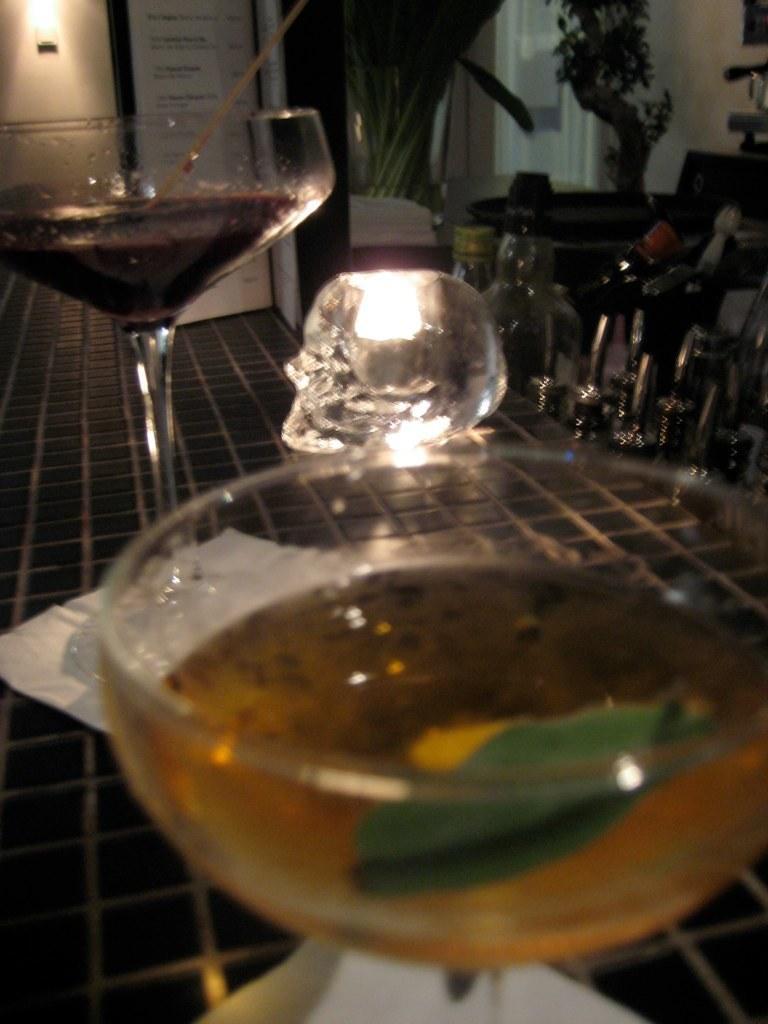Describe this image in one or two sentences. In this picture I can see there is some drink poured in the wine glasses and they are placed on the tissue. In the backdrop there is a light attached to wall and there are few objects and plants on to right. 